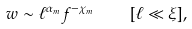Convert formula to latex. <formula><loc_0><loc_0><loc_500><loc_500>w \sim \ell ^ { \alpha _ { m } } f ^ { - \chi _ { m } } \quad [ \ell \ll \xi ] ,</formula> 